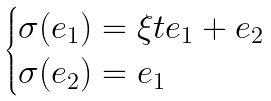<formula> <loc_0><loc_0><loc_500><loc_500>\begin{cases} \sigma ( e _ { 1 } ) = \xi t e _ { 1 } + e _ { 2 } \\ \sigma ( e _ { 2 } ) = e _ { 1 } \end{cases}</formula> 